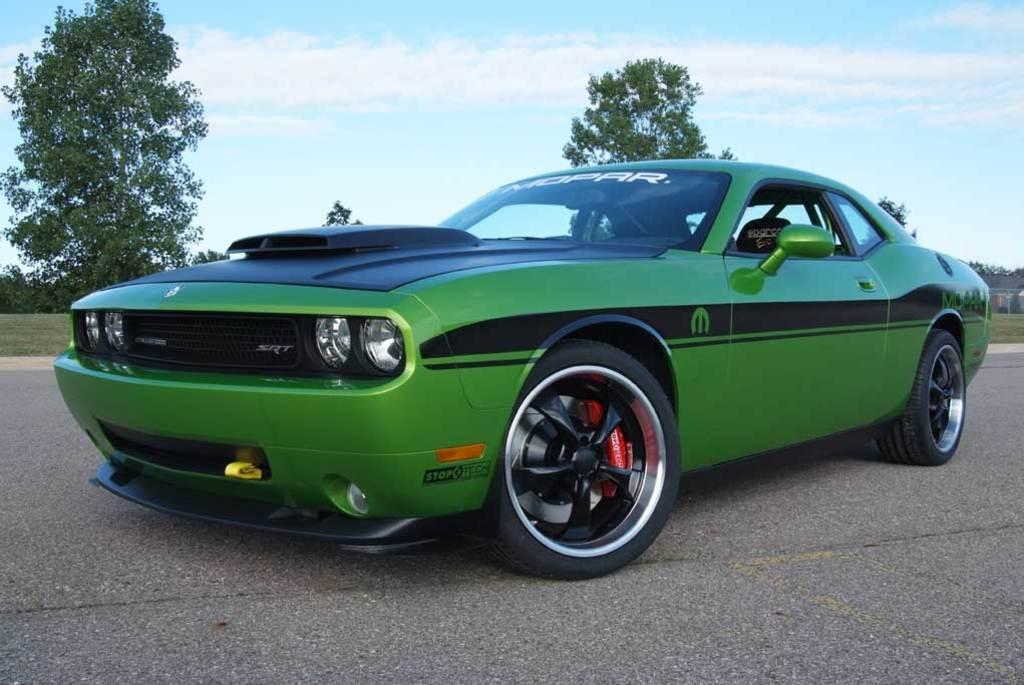Can you describe this image briefly? In this image we can see a car on the road. There is a grassy land in the image. There are clouds in the sky. There are many trees in the image. 